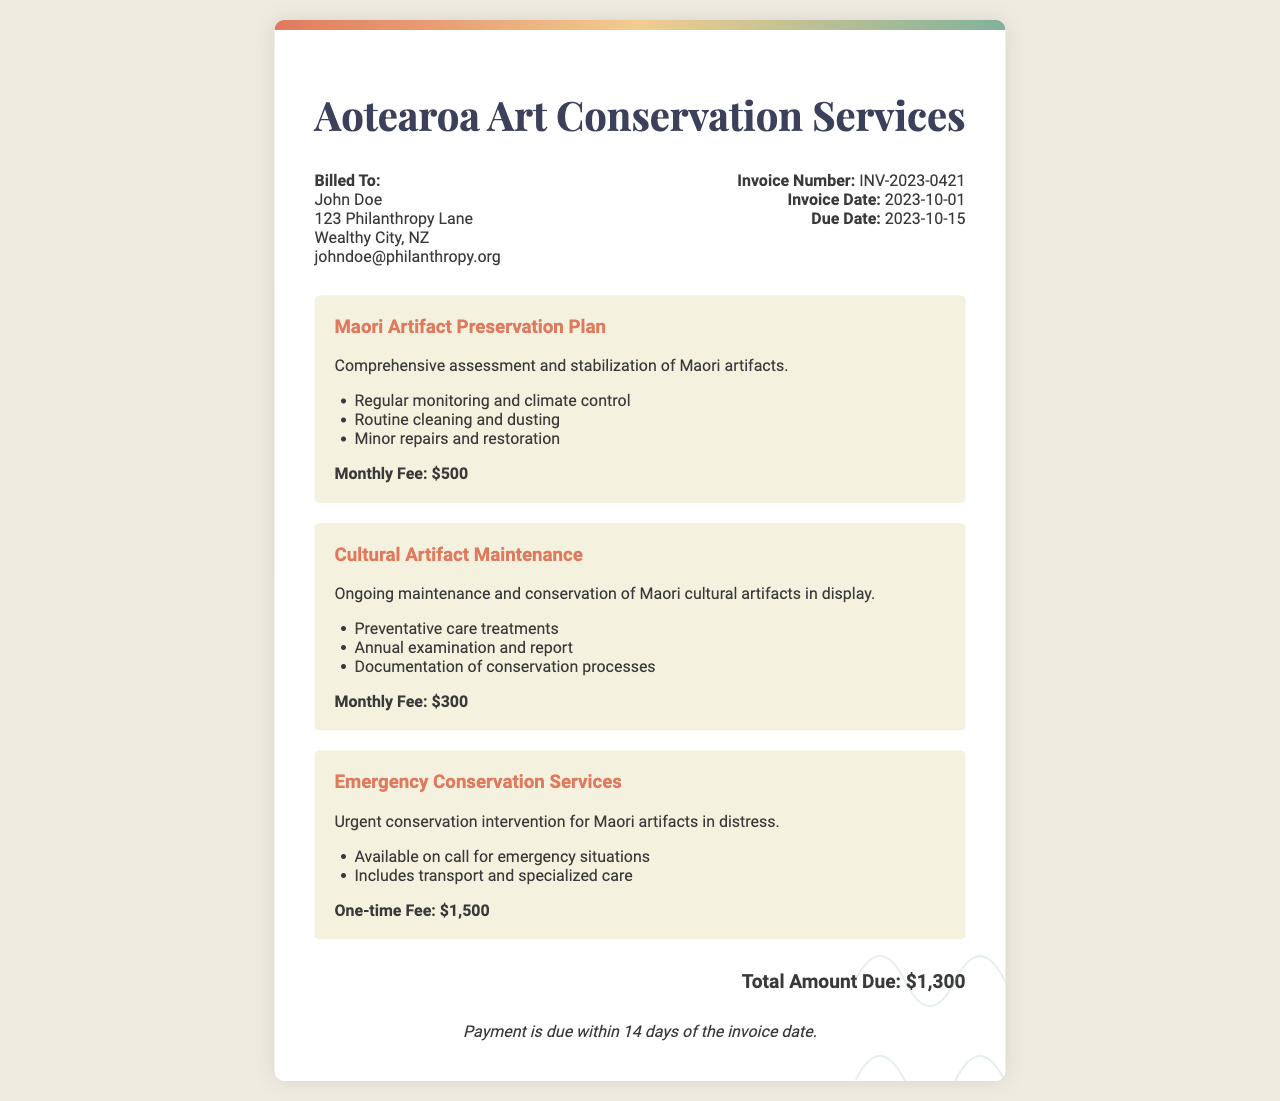What is the invoice number? The invoice number is a specific identifier for the document, which is noted as INV-2023-0421.
Answer: INV-2023-0421 What is the due date? The due date indicates when payment is required, which is mentioned as 2023-10-15.
Answer: 2023-10-15 Who is billed in this invoice? The invoice lists the person to be billed, who is John Doe according to the document.
Answer: John Doe What is the total amount due? The total amount due is the sum total presented towards the end of the invoice, specifically stated as $1,300.
Answer: $1,300 How much is the monthly fee for the Maori Artifact Preservation Plan? The monthly fee for this specific service is outlined in the document as $500.
Answer: $500 What type of service has a one-time fee? The service with a one-time fee is classified as Emergency Conservation Services in the invoice.
Answer: Emergency Conservation Services How often is the Cultural Artifact Maintenance examined? The invoice states that there is an annual examination included in the maintenance service.
Answer: Annual What is included in the Emergency Conservation Services? The specific details about the emergency services include urgent conservation intervention and transport for the artifacts.
Answer: Urgent conservation intervention What is the payment term outlined in the invoice? The payment terms detail how long the recipient has to make the payment, noted as 14 days from the invoice date.
Answer: 14 days 